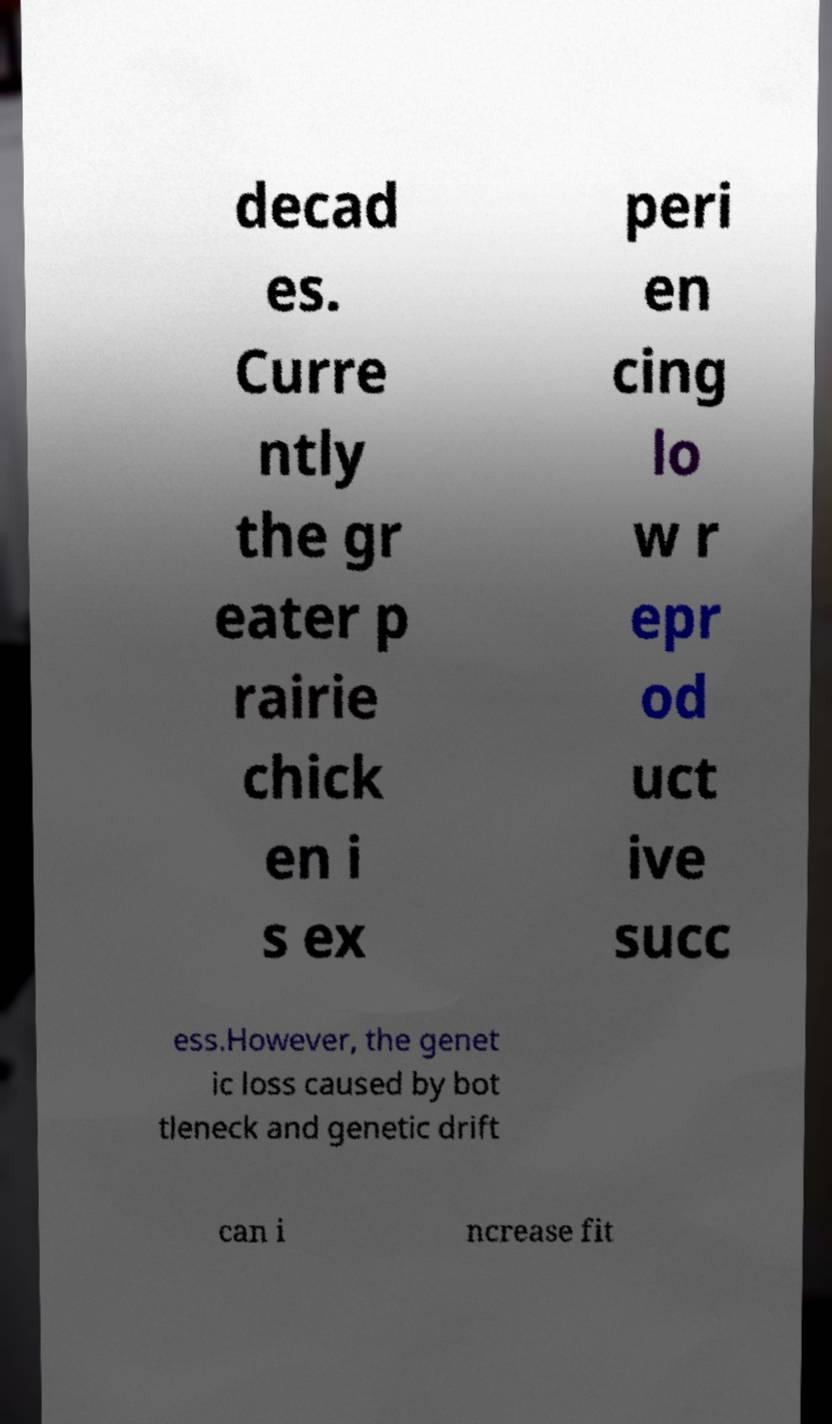Could you extract and type out the text from this image? decad es. Curre ntly the gr eater p rairie chick en i s ex peri en cing lo w r epr od uct ive succ ess.However, the genet ic loss caused by bot tleneck and genetic drift can i ncrease fit 